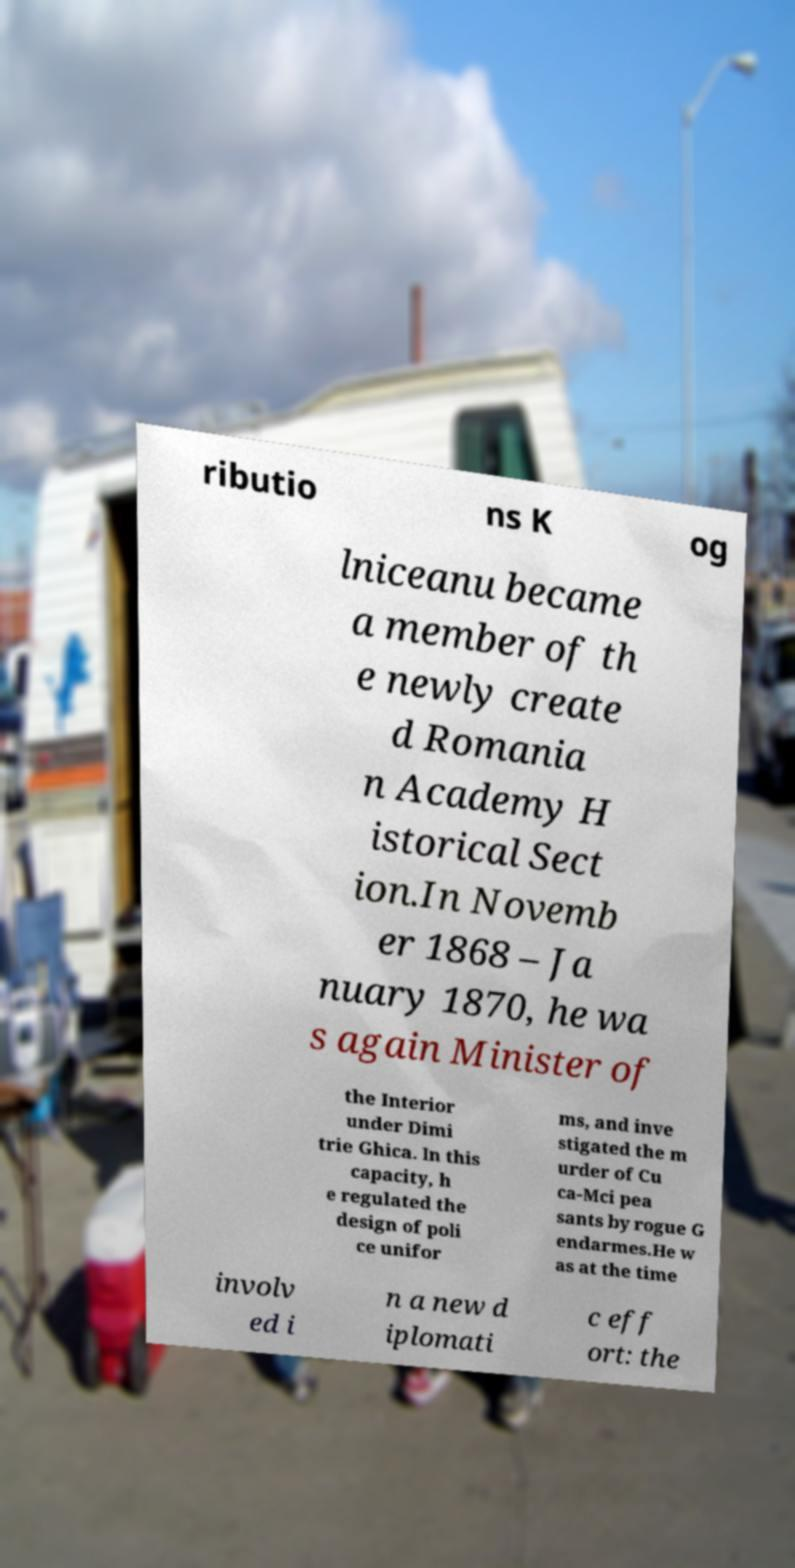I need the written content from this picture converted into text. Can you do that? ributio ns K og lniceanu became a member of th e newly create d Romania n Academy H istorical Sect ion.In Novemb er 1868 – Ja nuary 1870, he wa s again Minister of the Interior under Dimi trie Ghica. In this capacity, h e regulated the design of poli ce unifor ms, and inve stigated the m urder of Cu ca-Mci pea sants by rogue G endarmes.He w as at the time involv ed i n a new d iplomati c eff ort: the 